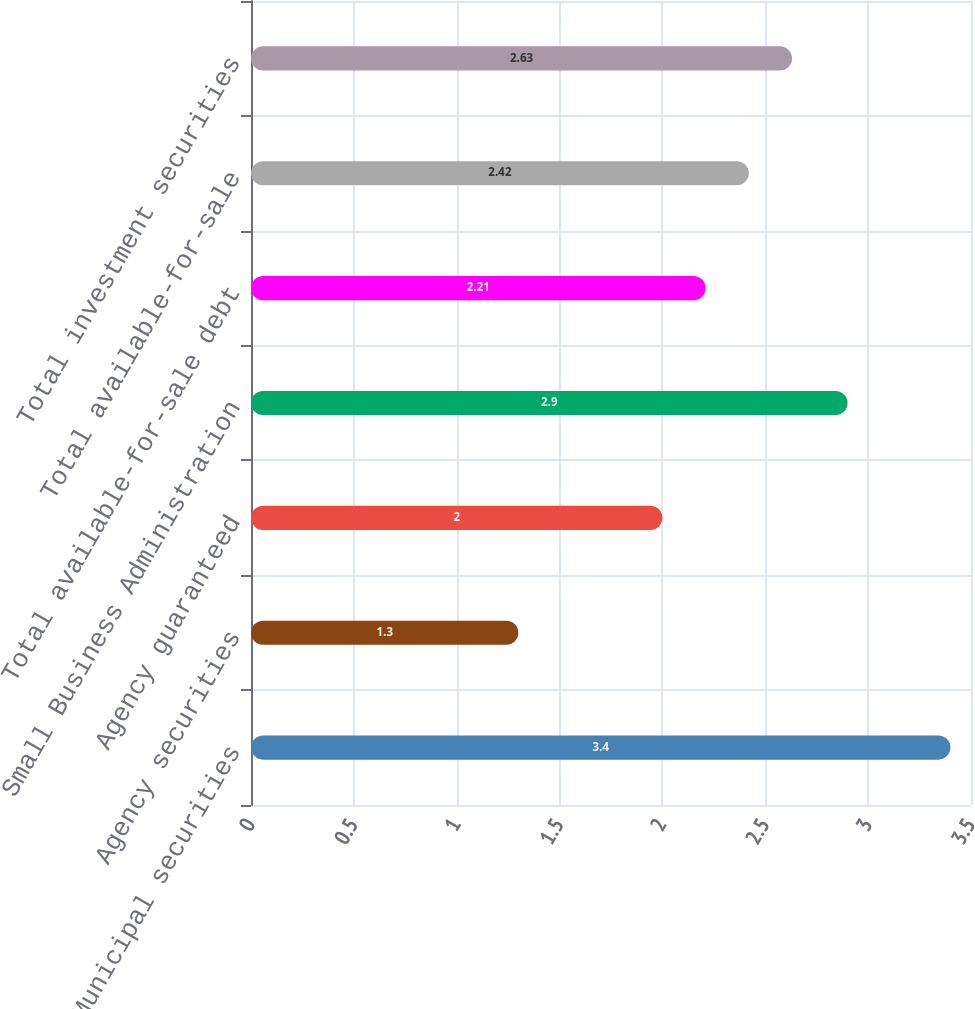Convert chart. <chart><loc_0><loc_0><loc_500><loc_500><bar_chart><fcel>Municipal securities<fcel>Agency securities<fcel>Agency guaranteed<fcel>Small Business Administration<fcel>Total available-for-sale debt<fcel>Total available-for-sale<fcel>Total investment securities<nl><fcel>3.4<fcel>1.3<fcel>2<fcel>2.9<fcel>2.21<fcel>2.42<fcel>2.63<nl></chart> 